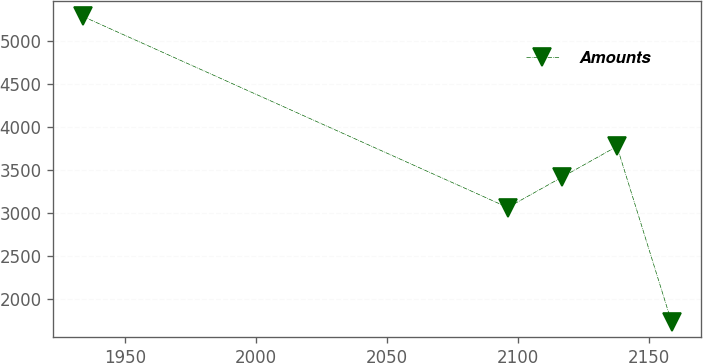<chart> <loc_0><loc_0><loc_500><loc_500><line_chart><ecel><fcel>Amounts<nl><fcel>1933.91<fcel>5282.24<nl><fcel>2096.07<fcel>3062.85<nl><fcel>2116.9<fcel>3417.82<nl><fcel>2137.73<fcel>3772.79<nl><fcel>2158.56<fcel>1732.5<nl></chart> 